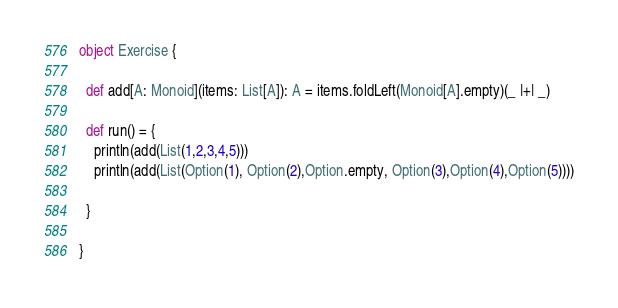Convert code to text. <code><loc_0><loc_0><loc_500><loc_500><_Scala_>object Exercise {

  def add[A: Monoid](items: List[A]): A = items.foldLeft(Monoid[A].empty)(_ |+| _)

  def run() = {
    println(add(List(1,2,3,4,5)))
    println(add(List(Option(1), Option(2),Option.empty, Option(3),Option(4),Option(5))))

  }

}
</code> 